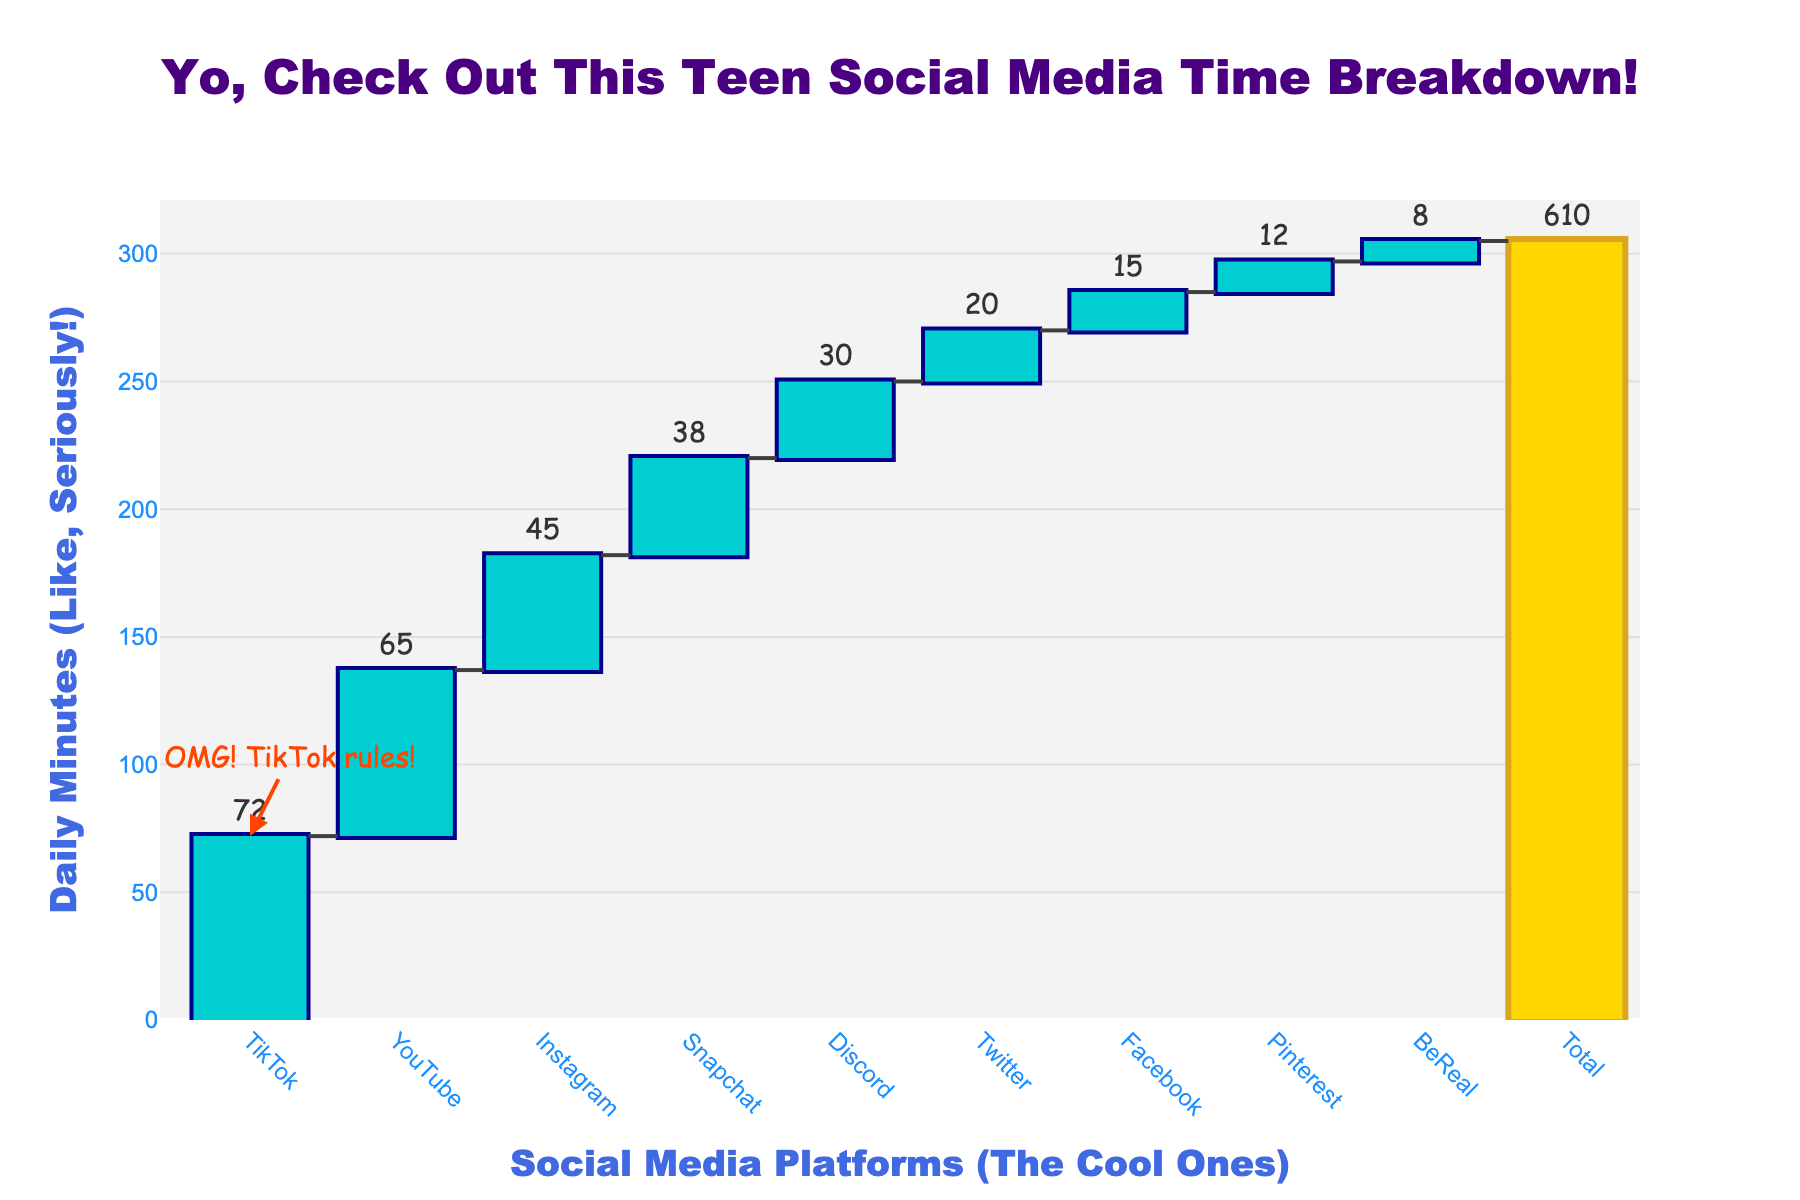What is the total daily social media usage time for teens? The figure shows the total daily social media usage time at the top of the waterfall chart labeled as 'Total.' This value is the sum of all individual platforms' usage times.
Answer: 305 minutes Which platform do teens spend the most time on daily? By looking at the height of the waterfall bars, the tallest bar represents the platform with the highest usage time, which is TikTok situated at the beginning of the chart.
Answer: TikTok How much more time do teens spend on YouTube compared to Snapchat? From the chart, find the values for YouTube (65 minutes) and Snapchat (38 minutes). Subtract Snapchat’s time from YouTube’s time.
Answer: 27 minutes What's the average daily time teens spend across all listed social media platforms (excluding Total)? Sum up the daily times for all platforms (excluding the total) and divide by the number of platforms (72 + 45 + 38 + 65 + 20 + 15 + 8 + 30 + 12 = 305; 305/9).
Answer: 33.89 minutes Which platform has the least usage time, and how much is it? Identify the shortest bar in the waterfall chart, BeReal, and check its time at the top of the bar.
Answer: BeReal, 8 minutes How does the daily time spent on Instagram compare to that on Discord? Find the daily times for Instagram (45 minutes) and Discord (30 minutes) from the waterfall heights. Subtract Discord’s time from Instagram’s time.
Answer: 15 minutes What is the proportion of time spent on TikTok compared to the total daily usage time? Take TikTok’s time (72 minutes) and divide it by the total usage (305 minutes). Convert the fraction to a percentage: (72/305) * 100.
Answer: 23.61% Which social media platform is marked with a special annotation, and what does it say? Look for the text annotation near one of the bars; TikTok is the platform with the annotation saying "OMG! TikTok rules!"
Answer: TikTok, "OMG! TikTok rules!" What is the combined daily time spent on Facebook and Pinterest? Add the daily times for Facebook (15 minutes) and Pinterest (12 minutes).
Answer: 27 minutes 